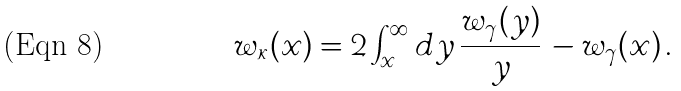Convert formula to latex. <formula><loc_0><loc_0><loc_500><loc_500>w _ { \kappa } ( x ) = 2 \int _ { x } ^ { \infty } d y \, \frac { w _ { \gamma } ( y ) } { y } \, - w _ { \gamma } ( x ) \, .</formula> 